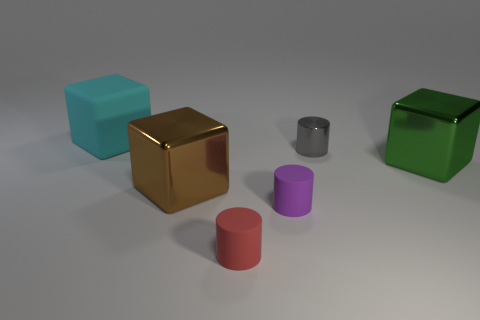There is a tiny purple object that is made of the same material as the big cyan cube; what is its shape? The tiny purple object you're referring to has a cylindrical shape, characterized by its circular base and uniform surface extending vertically from it, mirroring the geometric properties of a classic cylinder. 